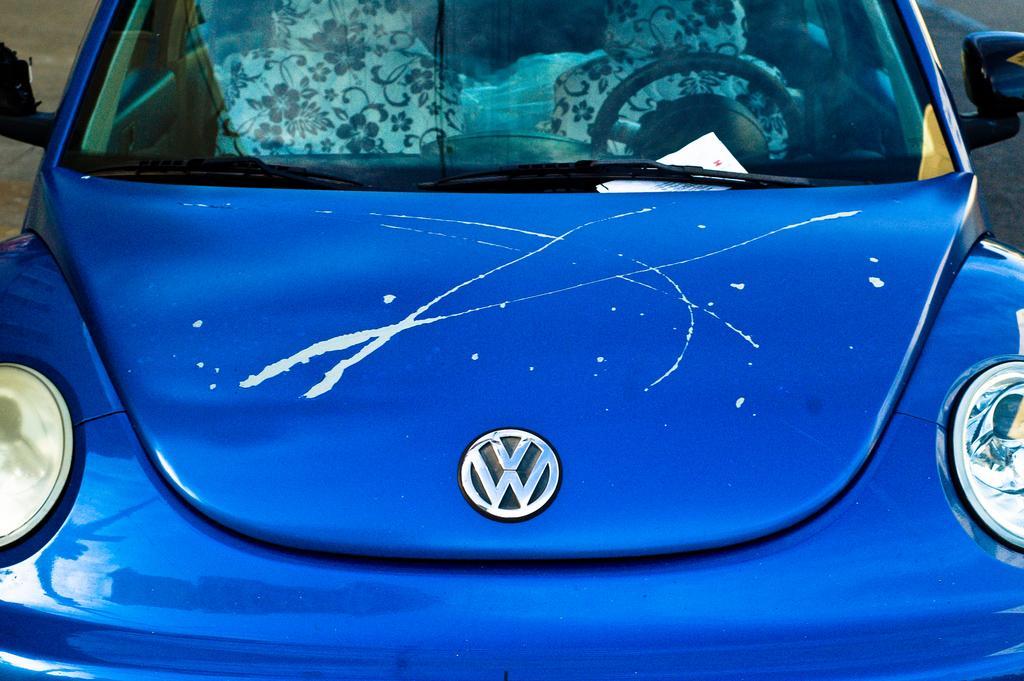Could you give a brief overview of what you see in this image? In this image we can see a car on the road and there is a paper on the car, through the glass we can see a steering and seats in the car. 